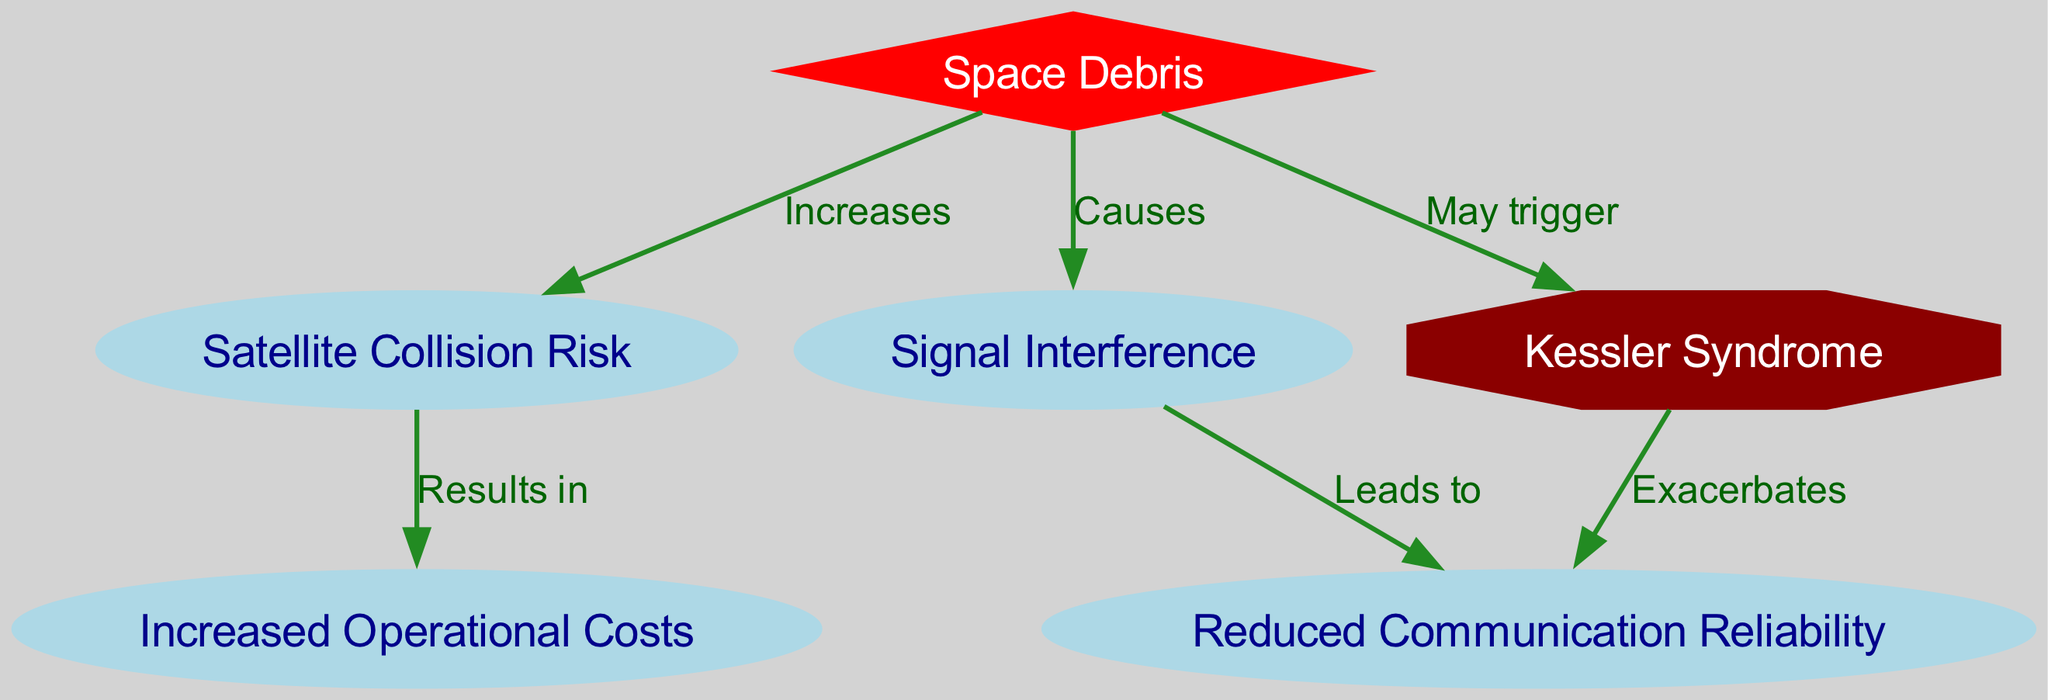What is the main type of debris discussed in the diagram? The diagram specifically focuses on "Space Debris" as the central node, which influences other nodes related to satellite communication.
Answer: Space Debris How many nodes are present in the diagram? By counting the unique circles and shapes present in the diagram, we find there are six nodes connected by edges, including "Space Debris", "Satellite Collision Risk", "Signal Interference", "Increased Operational Costs", "Reduced Communication Reliability", and "Kessler Syndrome".
Answer: Six What does space debris increase the risk of? The arrow from "Space Debris" to "Satellite Collision Risk" labeled "Increases" indicates that the primary effect of space debris is to heighten the risk of collisions between satellites.
Answer: Satellite Collision Risk What does signal interference lead to? Observing the edge from "Signal Interference" to "Reduced Communication Reliability," labeled "Leads to", shows that signal interference has a detrimental impact on the reliability of satellite communications.
Answer: Reduced Communication Reliability What potential event may be triggered by space debris? The diagram indicates that "Space Debris" may trigger an event listed as "Kessler Syndrome", which refers to a scenario where collision events could lead to more debris, compounding the problem.
Answer: Kessler Syndrome What are the results of satellite collisions? The diagram connects "Satellite Collision Risk" to "Increased Operational Costs" with the label "Results in", signifying that the risk of collisions leads to heightened costs for satellite operations to mitigate these risks.
Answer: Increased Operational Costs How does Kessler Syndrome affect reliability? The edge from "Kessler Syndrome" to "Reduced Communication Reliability" states it "Exacerbates" issues in communication reliability, indicating that once it occurs, it worsens the already existing reliability problems caused by space debris.
Answer: Reduced Communication Reliability What are the primary impacts of space debris on communication? The diagram shows that space debris affects communication primarily through increasing satellite collision risks, causing signal interference, and potentially leading to Kessler Syndrome, all contributing to decreased reliability and increased costs.
Answer: Satellite Collision Risk, Signal Interference, Kessler Syndrome, Increased Operational Costs 